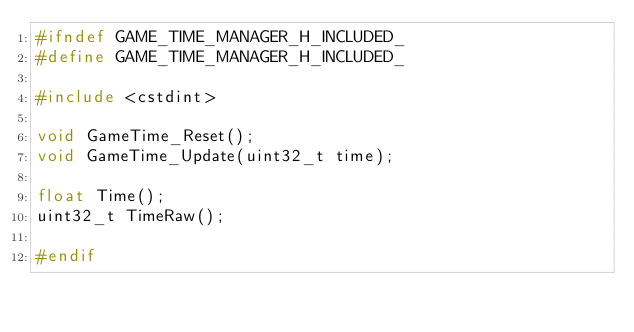Convert code to text. <code><loc_0><loc_0><loc_500><loc_500><_C_>#ifndef GAME_TIME_MANAGER_H_INCLUDED_
#define GAME_TIME_MANAGER_H_INCLUDED_

#include <cstdint>

void GameTime_Reset();
void GameTime_Update(uint32_t time);

float Time();
uint32_t TimeRaw();

#endif</code> 